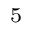Convert formula to latex. <formula><loc_0><loc_0><loc_500><loc_500>^ { 5 }</formula> 